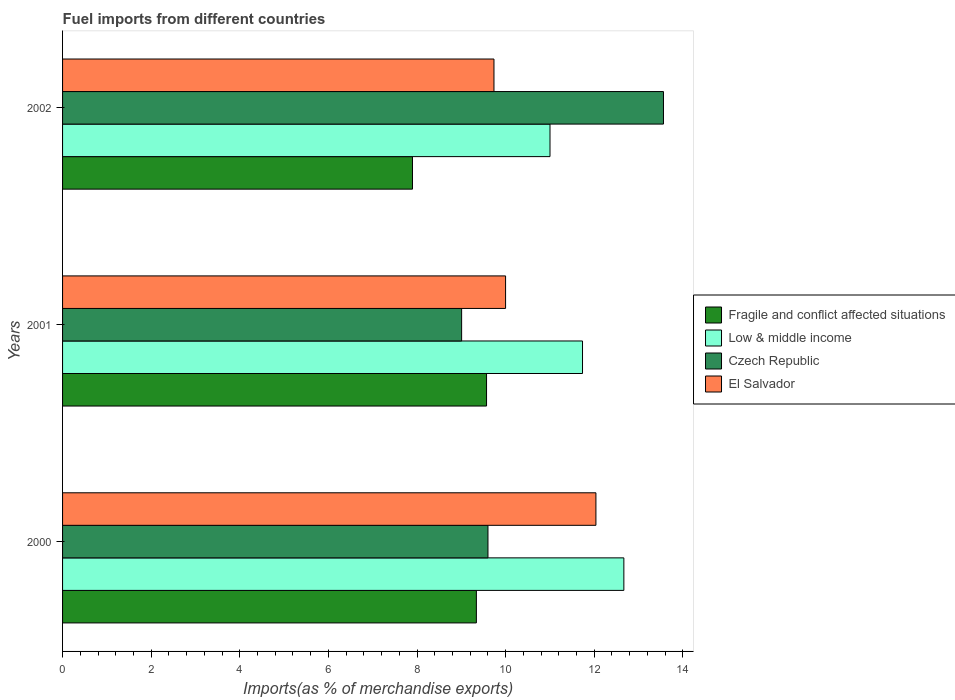How many groups of bars are there?
Offer a very short reply. 3. How many bars are there on the 3rd tick from the top?
Give a very brief answer. 4. What is the label of the 1st group of bars from the top?
Keep it short and to the point. 2002. What is the percentage of imports to different countries in Low & middle income in 2001?
Your answer should be compact. 11.74. Across all years, what is the maximum percentage of imports to different countries in Czech Republic?
Make the answer very short. 13.56. Across all years, what is the minimum percentage of imports to different countries in El Salvador?
Your response must be concise. 9.74. What is the total percentage of imports to different countries in El Salvador in the graph?
Make the answer very short. 31.77. What is the difference between the percentage of imports to different countries in Low & middle income in 2000 and that in 2002?
Give a very brief answer. 1.67. What is the difference between the percentage of imports to different countries in El Salvador in 2000 and the percentage of imports to different countries in Fragile and conflict affected situations in 2001?
Make the answer very short. 2.47. What is the average percentage of imports to different countries in Fragile and conflict affected situations per year?
Your answer should be compact. 8.94. In the year 2000, what is the difference between the percentage of imports to different countries in Low & middle income and percentage of imports to different countries in Czech Republic?
Ensure brevity in your answer.  3.07. What is the ratio of the percentage of imports to different countries in Czech Republic in 2000 to that in 2002?
Your answer should be compact. 0.71. Is the percentage of imports to different countries in El Salvador in 2000 less than that in 2002?
Make the answer very short. No. What is the difference between the highest and the second highest percentage of imports to different countries in Fragile and conflict affected situations?
Provide a succinct answer. 0.23. What is the difference between the highest and the lowest percentage of imports to different countries in El Salvador?
Keep it short and to the point. 2.3. In how many years, is the percentage of imports to different countries in Fragile and conflict affected situations greater than the average percentage of imports to different countries in Fragile and conflict affected situations taken over all years?
Provide a succinct answer. 2. Is the sum of the percentage of imports to different countries in El Salvador in 2001 and 2002 greater than the maximum percentage of imports to different countries in Czech Republic across all years?
Give a very brief answer. Yes. What does the 4th bar from the top in 2002 represents?
Give a very brief answer. Fragile and conflict affected situations. What does the 1st bar from the bottom in 2002 represents?
Ensure brevity in your answer.  Fragile and conflict affected situations. How many years are there in the graph?
Provide a short and direct response. 3. Does the graph contain any zero values?
Ensure brevity in your answer.  No. Does the graph contain grids?
Offer a very short reply. No. Where does the legend appear in the graph?
Offer a very short reply. Center right. What is the title of the graph?
Make the answer very short. Fuel imports from different countries. Does "India" appear as one of the legend labels in the graph?
Provide a succinct answer. No. What is the label or title of the X-axis?
Your answer should be compact. Imports(as % of merchandise exports). What is the label or title of the Y-axis?
Provide a succinct answer. Years. What is the Imports(as % of merchandise exports) of Fragile and conflict affected situations in 2000?
Give a very brief answer. 9.34. What is the Imports(as % of merchandise exports) in Low & middle income in 2000?
Provide a short and direct response. 12.67. What is the Imports(as % of merchandise exports) of Czech Republic in 2000?
Keep it short and to the point. 9.6. What is the Imports(as % of merchandise exports) in El Salvador in 2000?
Your answer should be compact. 12.04. What is the Imports(as % of merchandise exports) in Fragile and conflict affected situations in 2001?
Offer a very short reply. 9.57. What is the Imports(as % of merchandise exports) of Low & middle income in 2001?
Your answer should be very brief. 11.74. What is the Imports(as % of merchandise exports) of Czech Republic in 2001?
Your answer should be very brief. 9.01. What is the Imports(as % of merchandise exports) in El Salvador in 2001?
Give a very brief answer. 10. What is the Imports(as % of merchandise exports) of Fragile and conflict affected situations in 2002?
Your answer should be very brief. 7.9. What is the Imports(as % of merchandise exports) in Low & middle income in 2002?
Keep it short and to the point. 11. What is the Imports(as % of merchandise exports) of Czech Republic in 2002?
Your answer should be compact. 13.56. What is the Imports(as % of merchandise exports) in El Salvador in 2002?
Your answer should be very brief. 9.74. Across all years, what is the maximum Imports(as % of merchandise exports) in Fragile and conflict affected situations?
Your response must be concise. 9.57. Across all years, what is the maximum Imports(as % of merchandise exports) of Low & middle income?
Make the answer very short. 12.67. Across all years, what is the maximum Imports(as % of merchandise exports) of Czech Republic?
Make the answer very short. 13.56. Across all years, what is the maximum Imports(as % of merchandise exports) of El Salvador?
Offer a very short reply. 12.04. Across all years, what is the minimum Imports(as % of merchandise exports) in Fragile and conflict affected situations?
Your answer should be very brief. 7.9. Across all years, what is the minimum Imports(as % of merchandise exports) of Low & middle income?
Offer a very short reply. 11. Across all years, what is the minimum Imports(as % of merchandise exports) of Czech Republic?
Provide a short and direct response. 9.01. Across all years, what is the minimum Imports(as % of merchandise exports) in El Salvador?
Ensure brevity in your answer.  9.74. What is the total Imports(as % of merchandise exports) of Fragile and conflict affected situations in the graph?
Provide a short and direct response. 26.81. What is the total Imports(as % of merchandise exports) in Low & middle income in the graph?
Your response must be concise. 35.41. What is the total Imports(as % of merchandise exports) of Czech Republic in the graph?
Give a very brief answer. 32.17. What is the total Imports(as % of merchandise exports) in El Salvador in the graph?
Ensure brevity in your answer.  31.77. What is the difference between the Imports(as % of merchandise exports) of Fragile and conflict affected situations in 2000 and that in 2001?
Offer a very short reply. -0.23. What is the difference between the Imports(as % of merchandise exports) in Low & middle income in 2000 and that in 2001?
Ensure brevity in your answer.  0.93. What is the difference between the Imports(as % of merchandise exports) in Czech Republic in 2000 and that in 2001?
Keep it short and to the point. 0.59. What is the difference between the Imports(as % of merchandise exports) of El Salvador in 2000 and that in 2001?
Provide a succinct answer. 2.04. What is the difference between the Imports(as % of merchandise exports) in Fragile and conflict affected situations in 2000 and that in 2002?
Offer a terse response. 1.44. What is the difference between the Imports(as % of merchandise exports) in Low & middle income in 2000 and that in 2002?
Offer a very short reply. 1.67. What is the difference between the Imports(as % of merchandise exports) of Czech Republic in 2000 and that in 2002?
Provide a succinct answer. -3.96. What is the difference between the Imports(as % of merchandise exports) of El Salvador in 2000 and that in 2002?
Ensure brevity in your answer.  2.3. What is the difference between the Imports(as % of merchandise exports) of Fragile and conflict affected situations in 2001 and that in 2002?
Provide a short and direct response. 1.67. What is the difference between the Imports(as % of merchandise exports) of Low & middle income in 2001 and that in 2002?
Provide a short and direct response. 0.73. What is the difference between the Imports(as % of merchandise exports) in Czech Republic in 2001 and that in 2002?
Provide a succinct answer. -4.56. What is the difference between the Imports(as % of merchandise exports) in El Salvador in 2001 and that in 2002?
Provide a short and direct response. 0.26. What is the difference between the Imports(as % of merchandise exports) in Fragile and conflict affected situations in 2000 and the Imports(as % of merchandise exports) in Low & middle income in 2001?
Provide a short and direct response. -2.4. What is the difference between the Imports(as % of merchandise exports) of Fragile and conflict affected situations in 2000 and the Imports(as % of merchandise exports) of Czech Republic in 2001?
Offer a terse response. 0.33. What is the difference between the Imports(as % of merchandise exports) of Fragile and conflict affected situations in 2000 and the Imports(as % of merchandise exports) of El Salvador in 2001?
Your answer should be very brief. -0.66. What is the difference between the Imports(as % of merchandise exports) of Low & middle income in 2000 and the Imports(as % of merchandise exports) of Czech Republic in 2001?
Your response must be concise. 3.66. What is the difference between the Imports(as % of merchandise exports) of Low & middle income in 2000 and the Imports(as % of merchandise exports) of El Salvador in 2001?
Make the answer very short. 2.67. What is the difference between the Imports(as % of merchandise exports) in Czech Republic in 2000 and the Imports(as % of merchandise exports) in El Salvador in 2001?
Your answer should be very brief. -0.4. What is the difference between the Imports(as % of merchandise exports) in Fragile and conflict affected situations in 2000 and the Imports(as % of merchandise exports) in Low & middle income in 2002?
Provide a succinct answer. -1.66. What is the difference between the Imports(as % of merchandise exports) of Fragile and conflict affected situations in 2000 and the Imports(as % of merchandise exports) of Czech Republic in 2002?
Offer a very short reply. -4.22. What is the difference between the Imports(as % of merchandise exports) of Fragile and conflict affected situations in 2000 and the Imports(as % of merchandise exports) of El Salvador in 2002?
Offer a terse response. -0.4. What is the difference between the Imports(as % of merchandise exports) in Low & middle income in 2000 and the Imports(as % of merchandise exports) in Czech Republic in 2002?
Provide a short and direct response. -0.89. What is the difference between the Imports(as % of merchandise exports) in Low & middle income in 2000 and the Imports(as % of merchandise exports) in El Salvador in 2002?
Your answer should be very brief. 2.93. What is the difference between the Imports(as % of merchandise exports) of Czech Republic in 2000 and the Imports(as % of merchandise exports) of El Salvador in 2002?
Your answer should be very brief. -0.14. What is the difference between the Imports(as % of merchandise exports) of Fragile and conflict affected situations in 2001 and the Imports(as % of merchandise exports) of Low & middle income in 2002?
Ensure brevity in your answer.  -1.43. What is the difference between the Imports(as % of merchandise exports) of Fragile and conflict affected situations in 2001 and the Imports(as % of merchandise exports) of Czech Republic in 2002?
Your answer should be very brief. -3.99. What is the difference between the Imports(as % of merchandise exports) in Fragile and conflict affected situations in 2001 and the Imports(as % of merchandise exports) in El Salvador in 2002?
Your answer should be very brief. -0.17. What is the difference between the Imports(as % of merchandise exports) of Low & middle income in 2001 and the Imports(as % of merchandise exports) of Czech Republic in 2002?
Your response must be concise. -1.83. What is the difference between the Imports(as % of merchandise exports) in Low & middle income in 2001 and the Imports(as % of merchandise exports) in El Salvador in 2002?
Provide a short and direct response. 2. What is the difference between the Imports(as % of merchandise exports) in Czech Republic in 2001 and the Imports(as % of merchandise exports) in El Salvador in 2002?
Offer a terse response. -0.73. What is the average Imports(as % of merchandise exports) in Fragile and conflict affected situations per year?
Provide a succinct answer. 8.94. What is the average Imports(as % of merchandise exports) in Low & middle income per year?
Ensure brevity in your answer.  11.8. What is the average Imports(as % of merchandise exports) of Czech Republic per year?
Give a very brief answer. 10.72. What is the average Imports(as % of merchandise exports) in El Salvador per year?
Offer a very short reply. 10.59. In the year 2000, what is the difference between the Imports(as % of merchandise exports) of Fragile and conflict affected situations and Imports(as % of merchandise exports) of Low & middle income?
Your answer should be compact. -3.33. In the year 2000, what is the difference between the Imports(as % of merchandise exports) of Fragile and conflict affected situations and Imports(as % of merchandise exports) of Czech Republic?
Provide a short and direct response. -0.26. In the year 2000, what is the difference between the Imports(as % of merchandise exports) of Fragile and conflict affected situations and Imports(as % of merchandise exports) of El Salvador?
Offer a very short reply. -2.7. In the year 2000, what is the difference between the Imports(as % of merchandise exports) of Low & middle income and Imports(as % of merchandise exports) of Czech Republic?
Ensure brevity in your answer.  3.07. In the year 2000, what is the difference between the Imports(as % of merchandise exports) in Low & middle income and Imports(as % of merchandise exports) in El Salvador?
Make the answer very short. 0.63. In the year 2000, what is the difference between the Imports(as % of merchandise exports) of Czech Republic and Imports(as % of merchandise exports) of El Salvador?
Provide a succinct answer. -2.44. In the year 2001, what is the difference between the Imports(as % of merchandise exports) in Fragile and conflict affected situations and Imports(as % of merchandise exports) in Low & middle income?
Keep it short and to the point. -2.17. In the year 2001, what is the difference between the Imports(as % of merchandise exports) of Fragile and conflict affected situations and Imports(as % of merchandise exports) of Czech Republic?
Provide a short and direct response. 0.56. In the year 2001, what is the difference between the Imports(as % of merchandise exports) in Fragile and conflict affected situations and Imports(as % of merchandise exports) in El Salvador?
Offer a very short reply. -0.43. In the year 2001, what is the difference between the Imports(as % of merchandise exports) in Low & middle income and Imports(as % of merchandise exports) in Czech Republic?
Offer a terse response. 2.73. In the year 2001, what is the difference between the Imports(as % of merchandise exports) in Low & middle income and Imports(as % of merchandise exports) in El Salvador?
Your answer should be very brief. 1.74. In the year 2001, what is the difference between the Imports(as % of merchandise exports) of Czech Republic and Imports(as % of merchandise exports) of El Salvador?
Keep it short and to the point. -0.99. In the year 2002, what is the difference between the Imports(as % of merchandise exports) of Fragile and conflict affected situations and Imports(as % of merchandise exports) of Low & middle income?
Your response must be concise. -3.1. In the year 2002, what is the difference between the Imports(as % of merchandise exports) of Fragile and conflict affected situations and Imports(as % of merchandise exports) of Czech Republic?
Your answer should be very brief. -5.66. In the year 2002, what is the difference between the Imports(as % of merchandise exports) in Fragile and conflict affected situations and Imports(as % of merchandise exports) in El Salvador?
Your answer should be very brief. -1.84. In the year 2002, what is the difference between the Imports(as % of merchandise exports) in Low & middle income and Imports(as % of merchandise exports) in Czech Republic?
Your response must be concise. -2.56. In the year 2002, what is the difference between the Imports(as % of merchandise exports) in Low & middle income and Imports(as % of merchandise exports) in El Salvador?
Offer a terse response. 1.26. In the year 2002, what is the difference between the Imports(as % of merchandise exports) of Czech Republic and Imports(as % of merchandise exports) of El Salvador?
Provide a short and direct response. 3.83. What is the ratio of the Imports(as % of merchandise exports) of Low & middle income in 2000 to that in 2001?
Provide a succinct answer. 1.08. What is the ratio of the Imports(as % of merchandise exports) of Czech Republic in 2000 to that in 2001?
Provide a succinct answer. 1.07. What is the ratio of the Imports(as % of merchandise exports) in El Salvador in 2000 to that in 2001?
Provide a succinct answer. 1.2. What is the ratio of the Imports(as % of merchandise exports) in Fragile and conflict affected situations in 2000 to that in 2002?
Your answer should be compact. 1.18. What is the ratio of the Imports(as % of merchandise exports) of Low & middle income in 2000 to that in 2002?
Provide a succinct answer. 1.15. What is the ratio of the Imports(as % of merchandise exports) in Czech Republic in 2000 to that in 2002?
Your answer should be compact. 0.71. What is the ratio of the Imports(as % of merchandise exports) of El Salvador in 2000 to that in 2002?
Offer a very short reply. 1.24. What is the ratio of the Imports(as % of merchandise exports) of Fragile and conflict affected situations in 2001 to that in 2002?
Your response must be concise. 1.21. What is the ratio of the Imports(as % of merchandise exports) of Low & middle income in 2001 to that in 2002?
Your answer should be compact. 1.07. What is the ratio of the Imports(as % of merchandise exports) in Czech Republic in 2001 to that in 2002?
Make the answer very short. 0.66. What is the ratio of the Imports(as % of merchandise exports) of El Salvador in 2001 to that in 2002?
Your answer should be very brief. 1.03. What is the difference between the highest and the second highest Imports(as % of merchandise exports) in Fragile and conflict affected situations?
Offer a very short reply. 0.23. What is the difference between the highest and the second highest Imports(as % of merchandise exports) in Low & middle income?
Offer a very short reply. 0.93. What is the difference between the highest and the second highest Imports(as % of merchandise exports) of Czech Republic?
Make the answer very short. 3.96. What is the difference between the highest and the second highest Imports(as % of merchandise exports) of El Salvador?
Give a very brief answer. 2.04. What is the difference between the highest and the lowest Imports(as % of merchandise exports) of Fragile and conflict affected situations?
Provide a succinct answer. 1.67. What is the difference between the highest and the lowest Imports(as % of merchandise exports) in Low & middle income?
Your answer should be very brief. 1.67. What is the difference between the highest and the lowest Imports(as % of merchandise exports) in Czech Republic?
Offer a very short reply. 4.56. What is the difference between the highest and the lowest Imports(as % of merchandise exports) in El Salvador?
Offer a terse response. 2.3. 